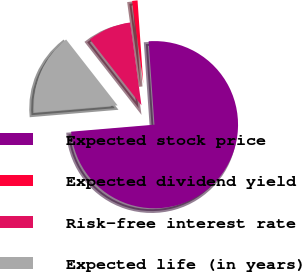Convert chart. <chart><loc_0><loc_0><loc_500><loc_500><pie_chart><fcel>Expected stock price<fcel>Expected dividend yield<fcel>Risk-free interest rate<fcel>Expected life (in years)<nl><fcel>74.77%<fcel>1.04%<fcel>8.41%<fcel>15.78%<nl></chart> 